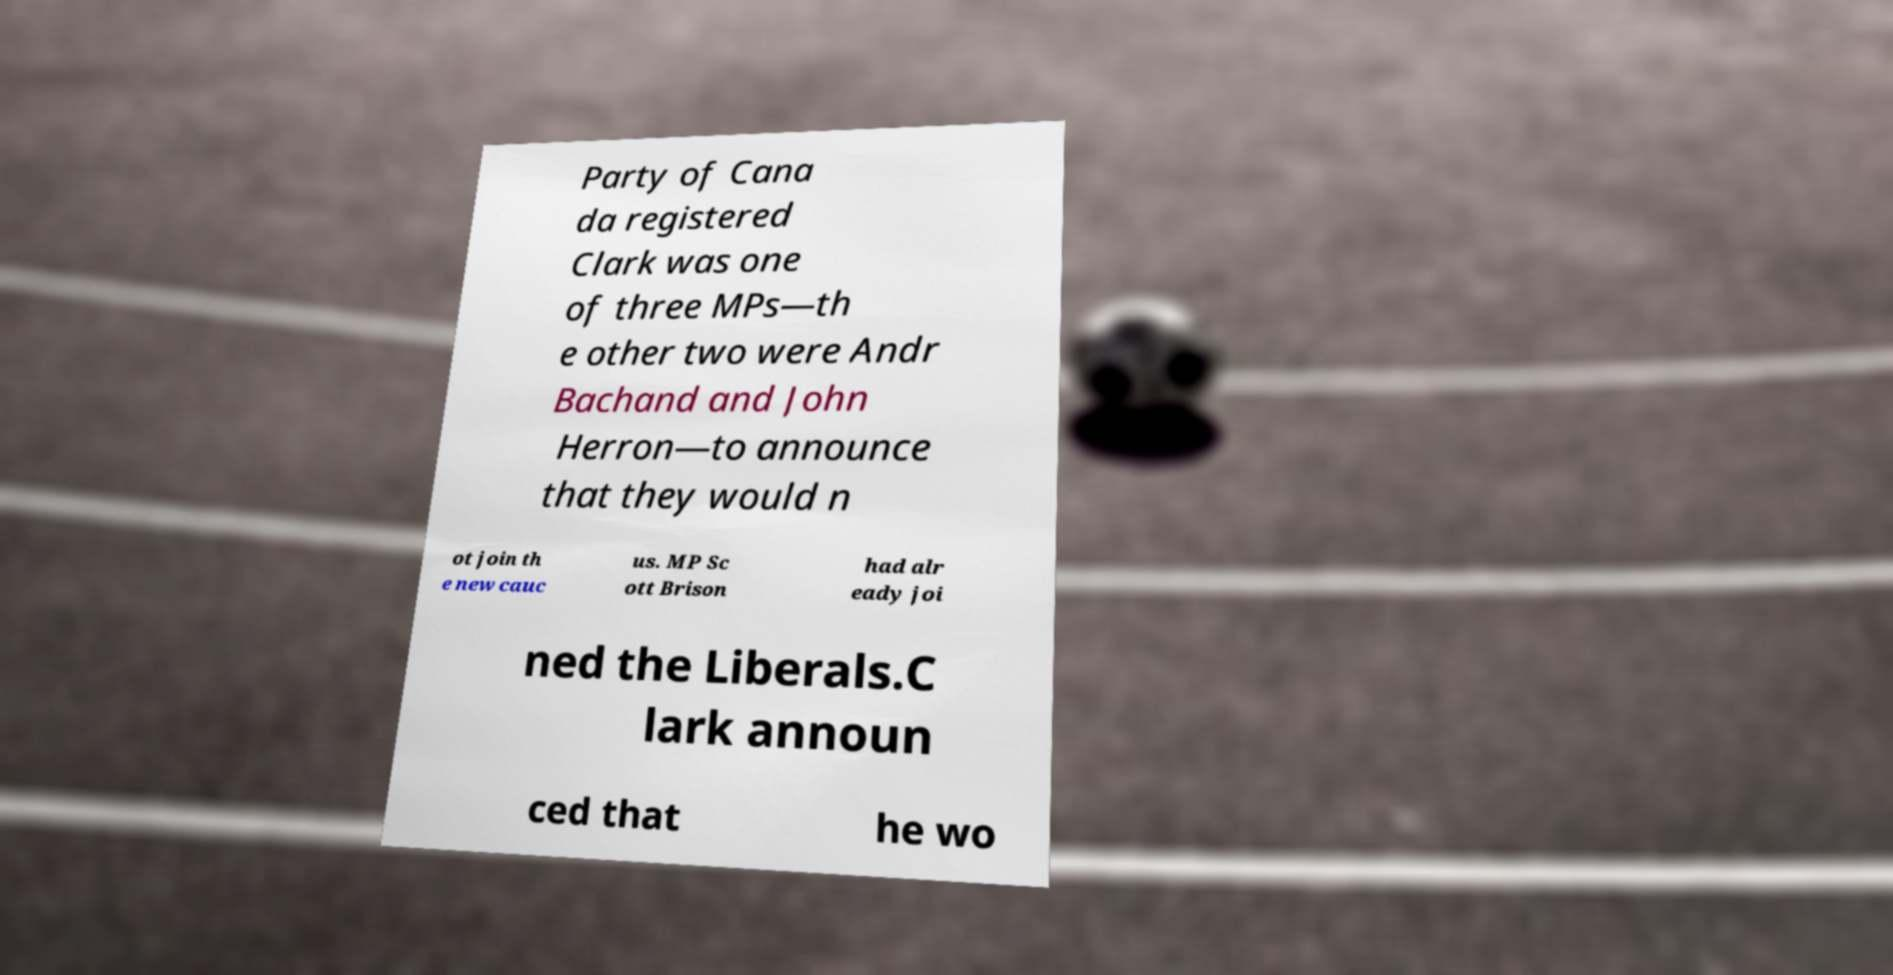I need the written content from this picture converted into text. Can you do that? Party of Cana da registered Clark was one of three MPs—th e other two were Andr Bachand and John Herron—to announce that they would n ot join th e new cauc us. MP Sc ott Brison had alr eady joi ned the Liberals.C lark announ ced that he wo 